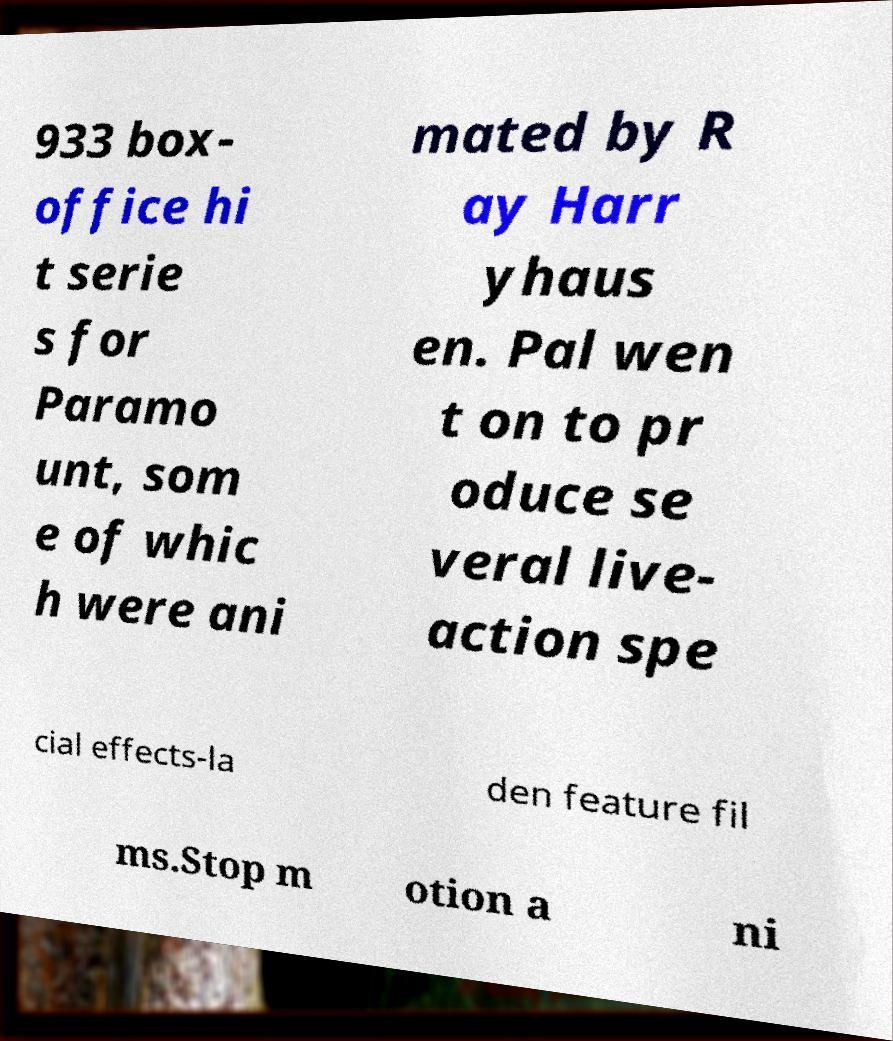For documentation purposes, I need the text within this image transcribed. Could you provide that? 933 box- office hi t serie s for Paramo unt, som e of whic h were ani mated by R ay Harr yhaus en. Pal wen t on to pr oduce se veral live- action spe cial effects-la den feature fil ms.Stop m otion a ni 